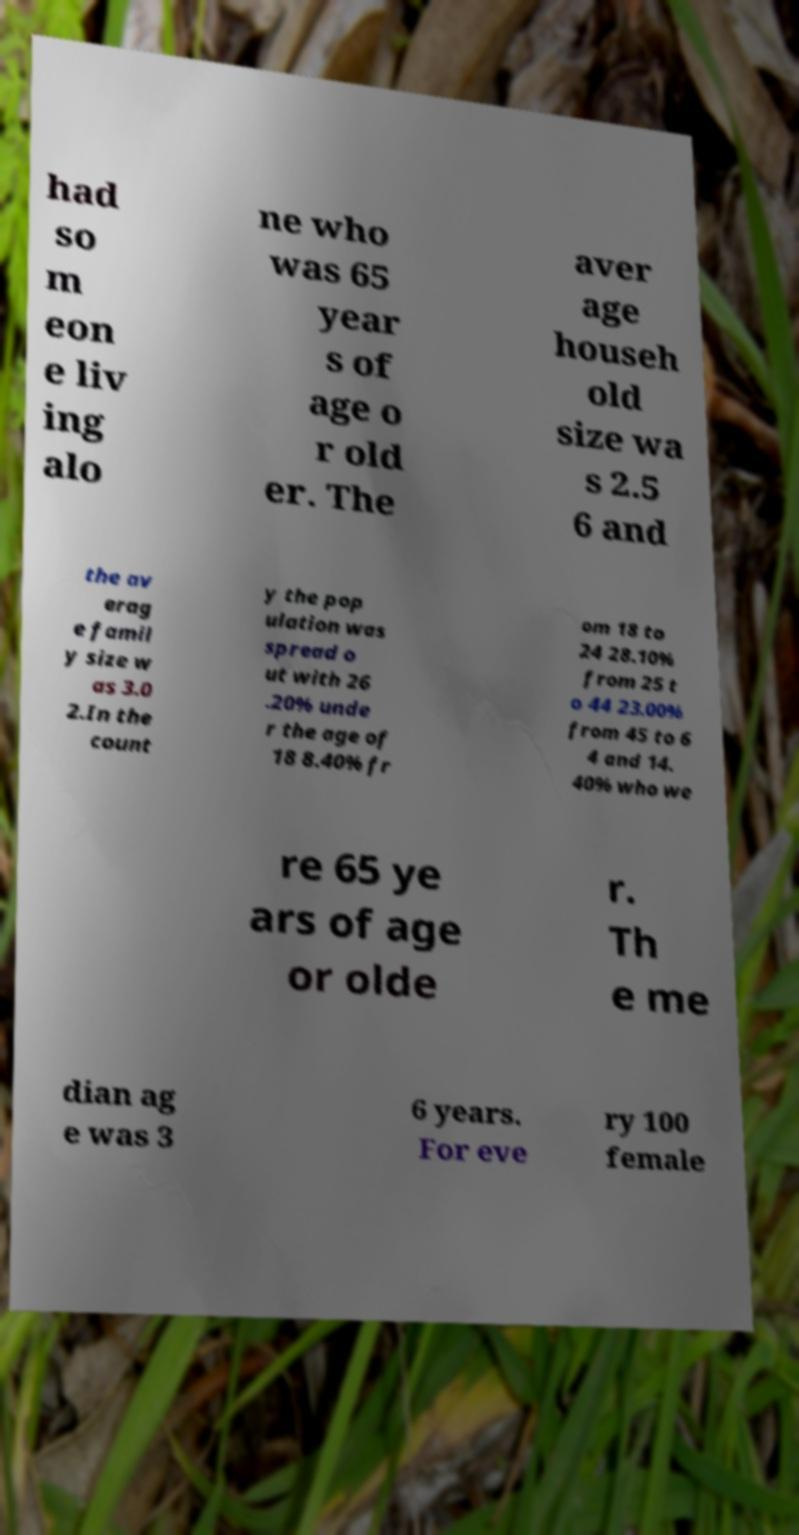Could you assist in decoding the text presented in this image and type it out clearly? had so m eon e liv ing alo ne who was 65 year s of age o r old er. The aver age househ old size wa s 2.5 6 and the av erag e famil y size w as 3.0 2.In the count y the pop ulation was spread o ut with 26 .20% unde r the age of 18 8.40% fr om 18 to 24 28.10% from 25 t o 44 23.00% from 45 to 6 4 and 14. 40% who we re 65 ye ars of age or olde r. Th e me dian ag e was 3 6 years. For eve ry 100 female 